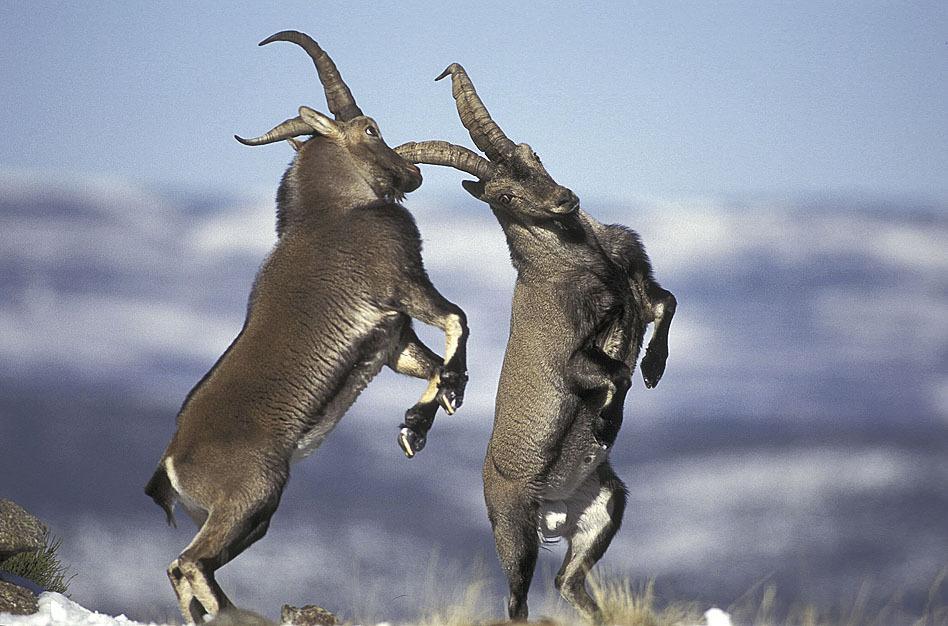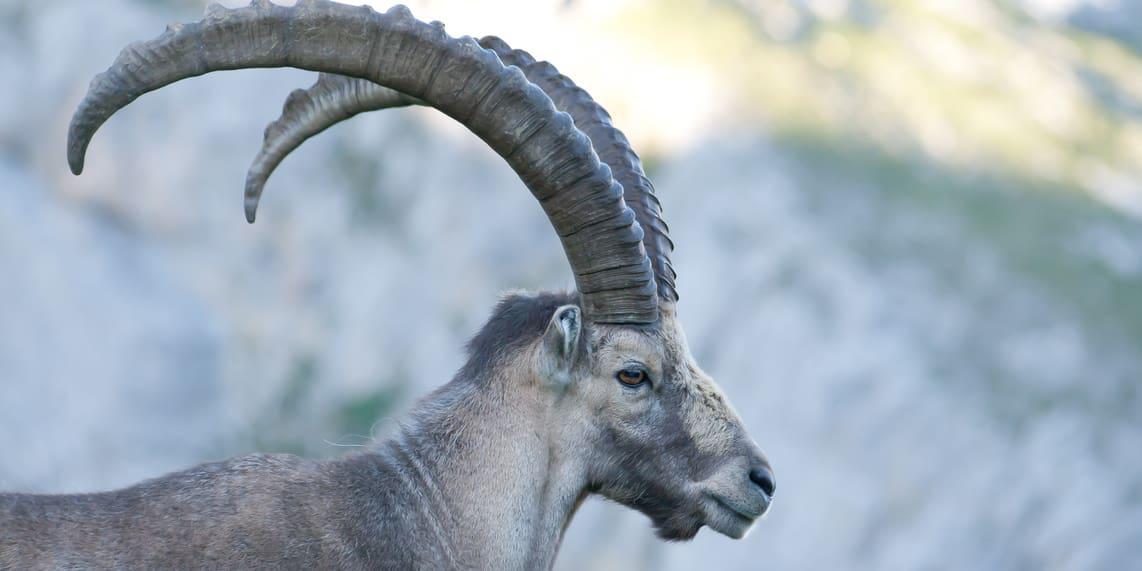The first image is the image on the left, the second image is the image on the right. For the images shown, is this caption "The left and right image contains the same number of goats." true? Answer yes or no. No. The first image is the image on the left, the second image is the image on the right. For the images displayed, is the sentence "One image contains one horned animal with its head in profile facing right, and the other image includes two hooved animals." factually correct? Answer yes or no. Yes. 